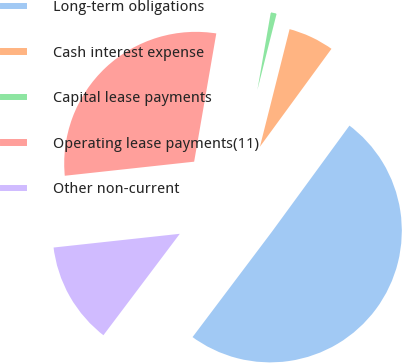Convert chart to OTSL. <chart><loc_0><loc_0><loc_500><loc_500><pie_chart><fcel>Long-term obligations<fcel>Cash interest expense<fcel>Capital lease payments<fcel>Operating lease payments(11)<fcel>Other non-current<nl><fcel>50.23%<fcel>6.11%<fcel>1.21%<fcel>29.45%<fcel>13.0%<nl></chart> 